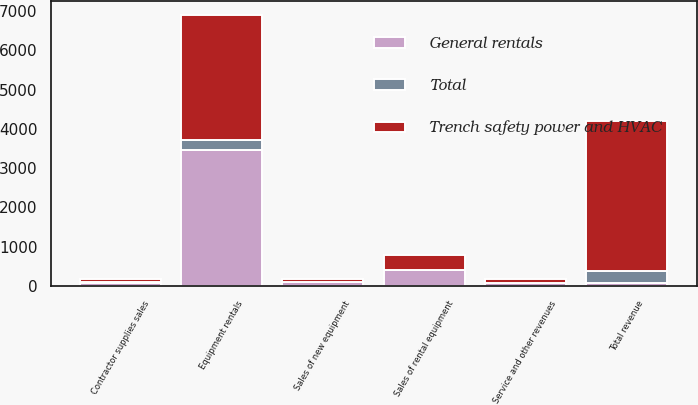Convert chart to OTSL. <chart><loc_0><loc_0><loc_500><loc_500><stacked_bar_chart><ecel><fcel>Equipment rentals<fcel>Sales of rental equipment<fcel>Sales of new equipment<fcel>Contractor supplies sales<fcel>Service and other revenues<fcel>Total revenue<nl><fcel>Trench safety power and HVAC<fcel>3188<fcel>387<fcel>86<fcel>80<fcel>79<fcel>3820<nl><fcel>Total<fcel>267<fcel>12<fcel>7<fcel>7<fcel>4<fcel>297<nl><fcel>General rentals<fcel>3455<fcel>399<fcel>93<fcel>87<fcel>83<fcel>87<nl></chart> 